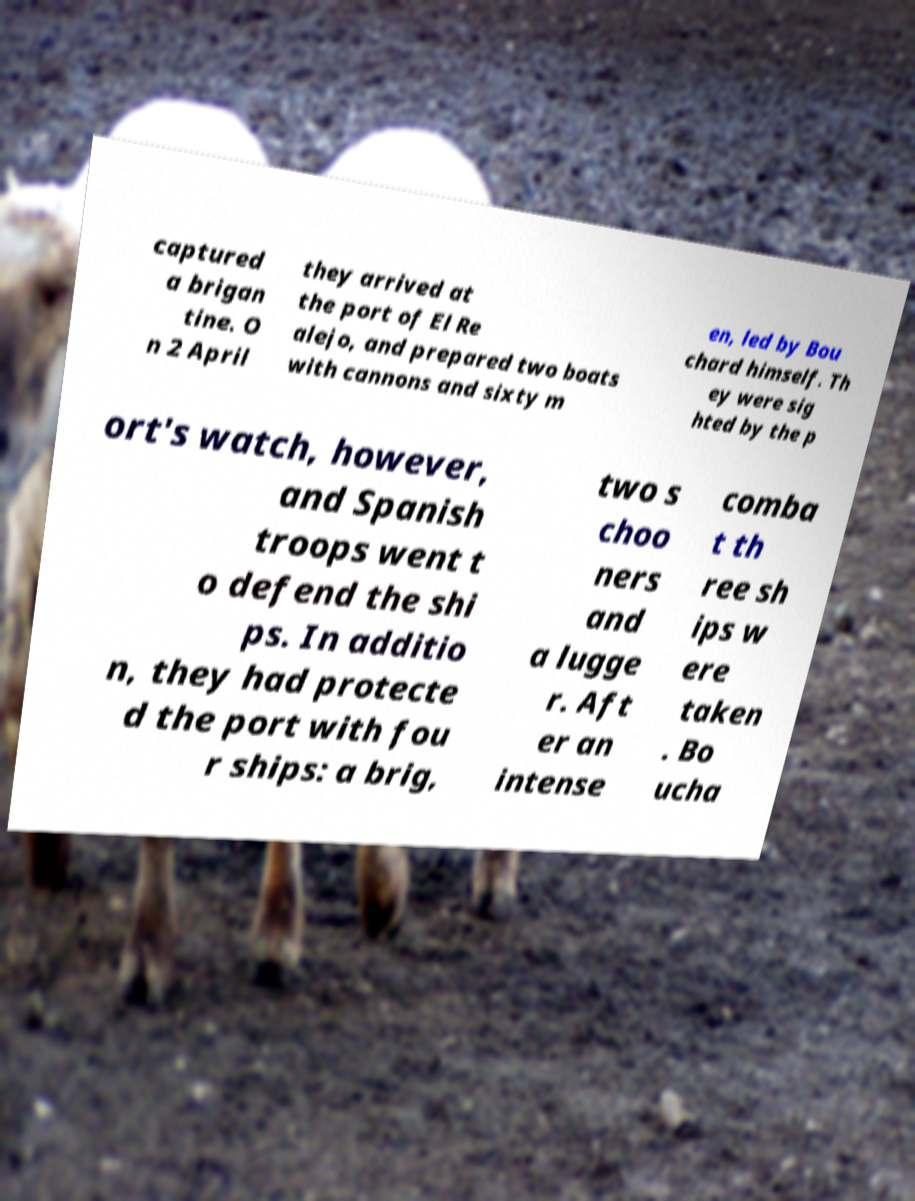What messages or text are displayed in this image? I need them in a readable, typed format. captured a brigan tine. O n 2 April they arrived at the port of El Re alejo, and prepared two boats with cannons and sixty m en, led by Bou chard himself. Th ey were sig hted by the p ort's watch, however, and Spanish troops went t o defend the shi ps. In additio n, they had protecte d the port with fou r ships: a brig, two s choo ners and a lugge r. Aft er an intense comba t th ree sh ips w ere taken . Bo ucha 